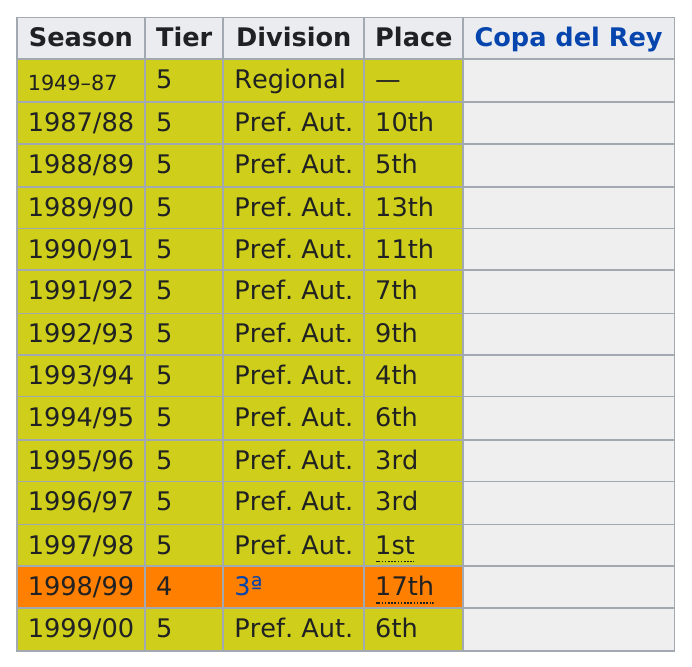Outline some significant characteristics in this image. In the season before 1999/00, a place was earned that was 17th. Finished above 5th place in 4 seasons. The 1995/96 season placed in the same position as the 1996/97 season in the ranking. Four teams have finished in 10th place or worse and completed four seasons. The 1997/1998 season placed first in its division. 